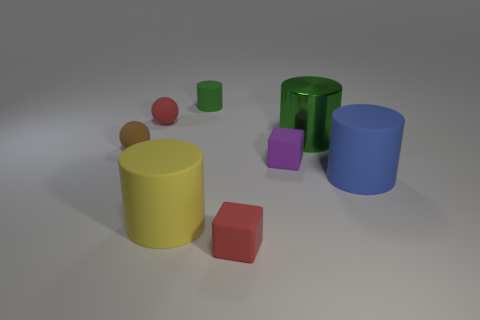Subtract all gray blocks. How many green cylinders are left? 2 Subtract all blue cylinders. How many cylinders are left? 3 Subtract all blue cylinders. How many cylinders are left? 3 Add 2 small red shiny spheres. How many objects exist? 10 Subtract all blocks. How many objects are left? 6 Subtract all purple cylinders. Subtract all gray cubes. How many cylinders are left? 4 Add 6 big green objects. How many big green objects are left? 7 Add 6 small green matte things. How many small green matte things exist? 7 Subtract 0 purple cylinders. How many objects are left? 8 Subtract all large shiny objects. Subtract all big shiny cylinders. How many objects are left? 6 